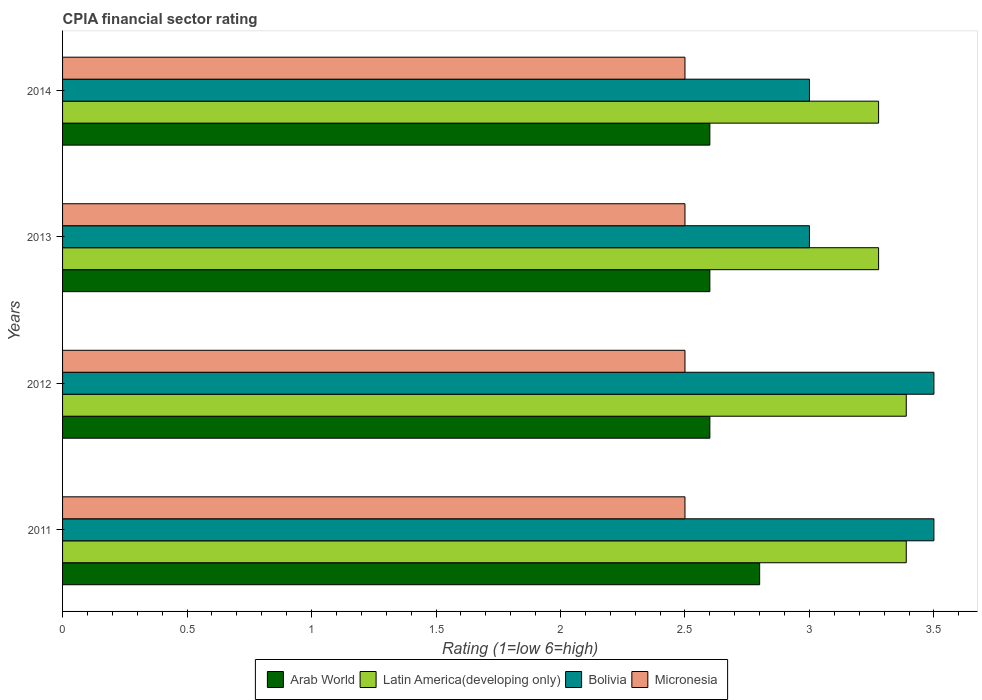How many bars are there on the 3rd tick from the top?
Your answer should be compact. 4. What is the label of the 1st group of bars from the top?
Offer a terse response. 2014. In how many cases, is the number of bars for a given year not equal to the number of legend labels?
Keep it short and to the point. 0. What is the CPIA rating in Latin America(developing only) in 2012?
Keep it short and to the point. 3.39. Across all years, what is the minimum CPIA rating in Bolivia?
Provide a succinct answer. 3. What is the difference between the CPIA rating in Bolivia in 2011 and that in 2014?
Provide a succinct answer. 0.5. What is the difference between the CPIA rating in Latin America(developing only) in 2014 and the CPIA rating in Micronesia in 2012?
Offer a very short reply. 0.78. What is the average CPIA rating in Arab World per year?
Make the answer very short. 2.65. In the year 2013, what is the difference between the CPIA rating in Micronesia and CPIA rating in Arab World?
Your answer should be very brief. -0.1. In how many years, is the CPIA rating in Latin America(developing only) greater than 3.2 ?
Give a very brief answer. 4. What is the ratio of the CPIA rating in Arab World in 2013 to that in 2014?
Your answer should be very brief. 1. Is the CPIA rating in Arab World in 2011 less than that in 2014?
Your answer should be compact. No. Is the difference between the CPIA rating in Micronesia in 2011 and 2013 greater than the difference between the CPIA rating in Arab World in 2011 and 2013?
Give a very brief answer. No. What is the difference between the highest and the second highest CPIA rating in Arab World?
Keep it short and to the point. 0.2. What is the difference between the highest and the lowest CPIA rating in Latin America(developing only)?
Your answer should be very brief. 0.11. Is the sum of the CPIA rating in Latin America(developing only) in 2011 and 2014 greater than the maximum CPIA rating in Micronesia across all years?
Offer a terse response. Yes. What does the 1st bar from the top in 2011 represents?
Keep it short and to the point. Micronesia. What does the 2nd bar from the bottom in 2012 represents?
Your answer should be very brief. Latin America(developing only). How many years are there in the graph?
Offer a terse response. 4. What is the difference between two consecutive major ticks on the X-axis?
Make the answer very short. 0.5. Does the graph contain any zero values?
Your answer should be very brief. No. Does the graph contain grids?
Keep it short and to the point. No. How many legend labels are there?
Provide a short and direct response. 4. What is the title of the graph?
Offer a very short reply. CPIA financial sector rating. Does "Gambia, The" appear as one of the legend labels in the graph?
Your answer should be compact. No. What is the Rating (1=low 6=high) in Latin America(developing only) in 2011?
Provide a succinct answer. 3.39. What is the Rating (1=low 6=high) of Micronesia in 2011?
Keep it short and to the point. 2.5. What is the Rating (1=low 6=high) in Arab World in 2012?
Offer a terse response. 2.6. What is the Rating (1=low 6=high) of Latin America(developing only) in 2012?
Provide a short and direct response. 3.39. What is the Rating (1=low 6=high) in Micronesia in 2012?
Provide a succinct answer. 2.5. What is the Rating (1=low 6=high) of Latin America(developing only) in 2013?
Your response must be concise. 3.28. What is the Rating (1=low 6=high) of Bolivia in 2013?
Provide a short and direct response. 3. What is the Rating (1=low 6=high) in Arab World in 2014?
Your answer should be compact. 2.6. What is the Rating (1=low 6=high) of Latin America(developing only) in 2014?
Provide a succinct answer. 3.28. What is the Rating (1=low 6=high) in Micronesia in 2014?
Provide a succinct answer. 2.5. Across all years, what is the maximum Rating (1=low 6=high) in Arab World?
Ensure brevity in your answer.  2.8. Across all years, what is the maximum Rating (1=low 6=high) in Latin America(developing only)?
Your answer should be compact. 3.39. Across all years, what is the maximum Rating (1=low 6=high) of Bolivia?
Provide a short and direct response. 3.5. Across all years, what is the minimum Rating (1=low 6=high) of Arab World?
Your answer should be compact. 2.6. Across all years, what is the minimum Rating (1=low 6=high) in Latin America(developing only)?
Your answer should be very brief. 3.28. What is the total Rating (1=low 6=high) in Arab World in the graph?
Keep it short and to the point. 10.6. What is the total Rating (1=low 6=high) of Latin America(developing only) in the graph?
Keep it short and to the point. 13.33. What is the difference between the Rating (1=low 6=high) in Arab World in 2011 and that in 2012?
Give a very brief answer. 0.2. What is the difference between the Rating (1=low 6=high) in Bolivia in 2011 and that in 2012?
Offer a terse response. 0. What is the difference between the Rating (1=low 6=high) in Micronesia in 2011 and that in 2012?
Provide a short and direct response. 0. What is the difference between the Rating (1=low 6=high) in Arab World in 2011 and that in 2013?
Provide a short and direct response. 0.2. What is the difference between the Rating (1=low 6=high) of Latin America(developing only) in 2011 and that in 2013?
Offer a very short reply. 0.11. What is the difference between the Rating (1=low 6=high) of Bolivia in 2011 and that in 2013?
Provide a succinct answer. 0.5. What is the difference between the Rating (1=low 6=high) in Arab World in 2011 and that in 2014?
Offer a terse response. 0.2. What is the difference between the Rating (1=low 6=high) of Bolivia in 2011 and that in 2014?
Offer a very short reply. 0.5. What is the difference between the Rating (1=low 6=high) in Arab World in 2012 and that in 2013?
Offer a very short reply. 0. What is the difference between the Rating (1=low 6=high) in Micronesia in 2012 and that in 2013?
Your answer should be very brief. 0. What is the difference between the Rating (1=low 6=high) of Latin America(developing only) in 2012 and that in 2014?
Your answer should be compact. 0.11. What is the difference between the Rating (1=low 6=high) of Micronesia in 2012 and that in 2014?
Offer a terse response. 0. What is the difference between the Rating (1=low 6=high) in Latin America(developing only) in 2013 and that in 2014?
Your answer should be compact. 0. What is the difference between the Rating (1=low 6=high) in Bolivia in 2013 and that in 2014?
Keep it short and to the point. 0. What is the difference between the Rating (1=low 6=high) in Micronesia in 2013 and that in 2014?
Ensure brevity in your answer.  0. What is the difference between the Rating (1=low 6=high) in Arab World in 2011 and the Rating (1=low 6=high) in Latin America(developing only) in 2012?
Make the answer very short. -0.59. What is the difference between the Rating (1=low 6=high) in Arab World in 2011 and the Rating (1=low 6=high) in Bolivia in 2012?
Ensure brevity in your answer.  -0.7. What is the difference between the Rating (1=low 6=high) in Arab World in 2011 and the Rating (1=low 6=high) in Micronesia in 2012?
Your response must be concise. 0.3. What is the difference between the Rating (1=low 6=high) in Latin America(developing only) in 2011 and the Rating (1=low 6=high) in Bolivia in 2012?
Offer a terse response. -0.11. What is the difference between the Rating (1=low 6=high) of Arab World in 2011 and the Rating (1=low 6=high) of Latin America(developing only) in 2013?
Provide a succinct answer. -0.48. What is the difference between the Rating (1=low 6=high) of Arab World in 2011 and the Rating (1=low 6=high) of Bolivia in 2013?
Your response must be concise. -0.2. What is the difference between the Rating (1=low 6=high) in Latin America(developing only) in 2011 and the Rating (1=low 6=high) in Bolivia in 2013?
Ensure brevity in your answer.  0.39. What is the difference between the Rating (1=low 6=high) of Latin America(developing only) in 2011 and the Rating (1=low 6=high) of Micronesia in 2013?
Make the answer very short. 0.89. What is the difference between the Rating (1=low 6=high) in Bolivia in 2011 and the Rating (1=low 6=high) in Micronesia in 2013?
Your response must be concise. 1. What is the difference between the Rating (1=low 6=high) in Arab World in 2011 and the Rating (1=low 6=high) in Latin America(developing only) in 2014?
Offer a terse response. -0.48. What is the difference between the Rating (1=low 6=high) in Arab World in 2011 and the Rating (1=low 6=high) in Micronesia in 2014?
Ensure brevity in your answer.  0.3. What is the difference between the Rating (1=low 6=high) of Latin America(developing only) in 2011 and the Rating (1=low 6=high) of Bolivia in 2014?
Provide a short and direct response. 0.39. What is the difference between the Rating (1=low 6=high) of Latin America(developing only) in 2011 and the Rating (1=low 6=high) of Micronesia in 2014?
Make the answer very short. 0.89. What is the difference between the Rating (1=low 6=high) of Arab World in 2012 and the Rating (1=low 6=high) of Latin America(developing only) in 2013?
Offer a very short reply. -0.68. What is the difference between the Rating (1=low 6=high) in Arab World in 2012 and the Rating (1=low 6=high) in Micronesia in 2013?
Provide a short and direct response. 0.1. What is the difference between the Rating (1=low 6=high) of Latin America(developing only) in 2012 and the Rating (1=low 6=high) of Bolivia in 2013?
Give a very brief answer. 0.39. What is the difference between the Rating (1=low 6=high) in Bolivia in 2012 and the Rating (1=low 6=high) in Micronesia in 2013?
Ensure brevity in your answer.  1. What is the difference between the Rating (1=low 6=high) in Arab World in 2012 and the Rating (1=low 6=high) in Latin America(developing only) in 2014?
Ensure brevity in your answer.  -0.68. What is the difference between the Rating (1=low 6=high) of Latin America(developing only) in 2012 and the Rating (1=low 6=high) of Bolivia in 2014?
Keep it short and to the point. 0.39. What is the difference between the Rating (1=low 6=high) in Latin America(developing only) in 2012 and the Rating (1=low 6=high) in Micronesia in 2014?
Make the answer very short. 0.89. What is the difference between the Rating (1=low 6=high) of Arab World in 2013 and the Rating (1=low 6=high) of Latin America(developing only) in 2014?
Make the answer very short. -0.68. What is the difference between the Rating (1=low 6=high) in Arab World in 2013 and the Rating (1=low 6=high) in Bolivia in 2014?
Ensure brevity in your answer.  -0.4. What is the difference between the Rating (1=low 6=high) of Arab World in 2013 and the Rating (1=low 6=high) of Micronesia in 2014?
Give a very brief answer. 0.1. What is the difference between the Rating (1=low 6=high) in Latin America(developing only) in 2013 and the Rating (1=low 6=high) in Bolivia in 2014?
Your answer should be very brief. 0.28. What is the average Rating (1=low 6=high) of Arab World per year?
Make the answer very short. 2.65. What is the average Rating (1=low 6=high) in Bolivia per year?
Offer a very short reply. 3.25. In the year 2011, what is the difference between the Rating (1=low 6=high) in Arab World and Rating (1=low 6=high) in Latin America(developing only)?
Offer a very short reply. -0.59. In the year 2011, what is the difference between the Rating (1=low 6=high) in Arab World and Rating (1=low 6=high) in Micronesia?
Provide a short and direct response. 0.3. In the year 2011, what is the difference between the Rating (1=low 6=high) of Latin America(developing only) and Rating (1=low 6=high) of Bolivia?
Ensure brevity in your answer.  -0.11. In the year 2011, what is the difference between the Rating (1=low 6=high) in Latin America(developing only) and Rating (1=low 6=high) in Micronesia?
Your response must be concise. 0.89. In the year 2011, what is the difference between the Rating (1=low 6=high) of Bolivia and Rating (1=low 6=high) of Micronesia?
Keep it short and to the point. 1. In the year 2012, what is the difference between the Rating (1=low 6=high) in Arab World and Rating (1=low 6=high) in Latin America(developing only)?
Your answer should be very brief. -0.79. In the year 2012, what is the difference between the Rating (1=low 6=high) in Arab World and Rating (1=low 6=high) in Micronesia?
Your answer should be compact. 0.1. In the year 2012, what is the difference between the Rating (1=low 6=high) in Latin America(developing only) and Rating (1=low 6=high) in Bolivia?
Provide a succinct answer. -0.11. In the year 2013, what is the difference between the Rating (1=low 6=high) in Arab World and Rating (1=low 6=high) in Latin America(developing only)?
Give a very brief answer. -0.68. In the year 2013, what is the difference between the Rating (1=low 6=high) of Arab World and Rating (1=low 6=high) of Bolivia?
Make the answer very short. -0.4. In the year 2013, what is the difference between the Rating (1=low 6=high) in Arab World and Rating (1=low 6=high) in Micronesia?
Your answer should be compact. 0.1. In the year 2013, what is the difference between the Rating (1=low 6=high) of Latin America(developing only) and Rating (1=low 6=high) of Bolivia?
Offer a terse response. 0.28. In the year 2013, what is the difference between the Rating (1=low 6=high) in Latin America(developing only) and Rating (1=low 6=high) in Micronesia?
Keep it short and to the point. 0.78. In the year 2014, what is the difference between the Rating (1=low 6=high) in Arab World and Rating (1=low 6=high) in Latin America(developing only)?
Your response must be concise. -0.68. In the year 2014, what is the difference between the Rating (1=low 6=high) in Arab World and Rating (1=low 6=high) in Micronesia?
Your response must be concise. 0.1. In the year 2014, what is the difference between the Rating (1=low 6=high) of Latin America(developing only) and Rating (1=low 6=high) of Bolivia?
Give a very brief answer. 0.28. In the year 2014, what is the difference between the Rating (1=low 6=high) in Latin America(developing only) and Rating (1=low 6=high) in Micronesia?
Make the answer very short. 0.78. In the year 2014, what is the difference between the Rating (1=low 6=high) of Bolivia and Rating (1=low 6=high) of Micronesia?
Offer a very short reply. 0.5. What is the ratio of the Rating (1=low 6=high) of Bolivia in 2011 to that in 2012?
Offer a very short reply. 1. What is the ratio of the Rating (1=low 6=high) of Latin America(developing only) in 2011 to that in 2013?
Ensure brevity in your answer.  1.03. What is the ratio of the Rating (1=low 6=high) in Bolivia in 2011 to that in 2013?
Ensure brevity in your answer.  1.17. What is the ratio of the Rating (1=low 6=high) of Latin America(developing only) in 2011 to that in 2014?
Your response must be concise. 1.03. What is the ratio of the Rating (1=low 6=high) of Arab World in 2012 to that in 2013?
Offer a very short reply. 1. What is the ratio of the Rating (1=low 6=high) in Latin America(developing only) in 2012 to that in 2013?
Ensure brevity in your answer.  1.03. What is the ratio of the Rating (1=low 6=high) of Arab World in 2012 to that in 2014?
Ensure brevity in your answer.  1. What is the ratio of the Rating (1=low 6=high) in Latin America(developing only) in 2012 to that in 2014?
Offer a terse response. 1.03. What is the ratio of the Rating (1=low 6=high) of Bolivia in 2012 to that in 2014?
Give a very brief answer. 1.17. What is the ratio of the Rating (1=low 6=high) of Micronesia in 2012 to that in 2014?
Ensure brevity in your answer.  1. What is the ratio of the Rating (1=low 6=high) of Latin America(developing only) in 2013 to that in 2014?
Give a very brief answer. 1. What is the ratio of the Rating (1=low 6=high) in Micronesia in 2013 to that in 2014?
Provide a succinct answer. 1. What is the difference between the highest and the second highest Rating (1=low 6=high) of Arab World?
Offer a terse response. 0.2. What is the difference between the highest and the second highest Rating (1=low 6=high) in Bolivia?
Offer a very short reply. 0. What is the difference between the highest and the second highest Rating (1=low 6=high) of Micronesia?
Provide a short and direct response. 0. What is the difference between the highest and the lowest Rating (1=low 6=high) in Arab World?
Give a very brief answer. 0.2. What is the difference between the highest and the lowest Rating (1=low 6=high) in Latin America(developing only)?
Your response must be concise. 0.11. What is the difference between the highest and the lowest Rating (1=low 6=high) in Bolivia?
Offer a very short reply. 0.5. 